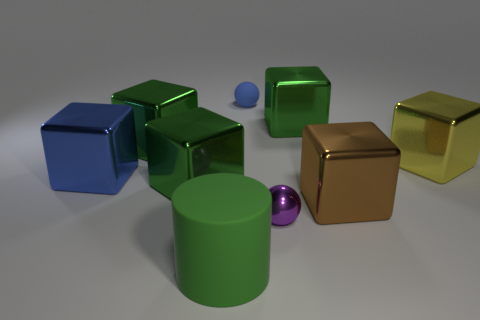Subtract all yellow spheres. How many green cubes are left? 3 Subtract all yellow cubes. How many cubes are left? 5 Subtract all blue blocks. How many blocks are left? 5 Subtract 1 blocks. How many blocks are left? 5 Subtract all blue balls. Subtract all red blocks. How many balls are left? 1 Add 1 large brown objects. How many objects exist? 10 Subtract all cylinders. How many objects are left? 8 Subtract 0 cyan cylinders. How many objects are left? 9 Subtract all large green spheres. Subtract all green cylinders. How many objects are left? 8 Add 6 purple spheres. How many purple spheres are left? 7 